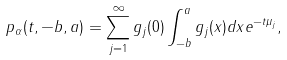<formula> <loc_0><loc_0><loc_500><loc_500>p _ { \alpha } ( t , - b , a ) = \sum _ { j = 1 } ^ { \infty } g _ { j } ( 0 ) \int _ { - b } ^ { a } g _ { j } ( x ) d x e ^ { - t \mu _ { j } } ,</formula> 